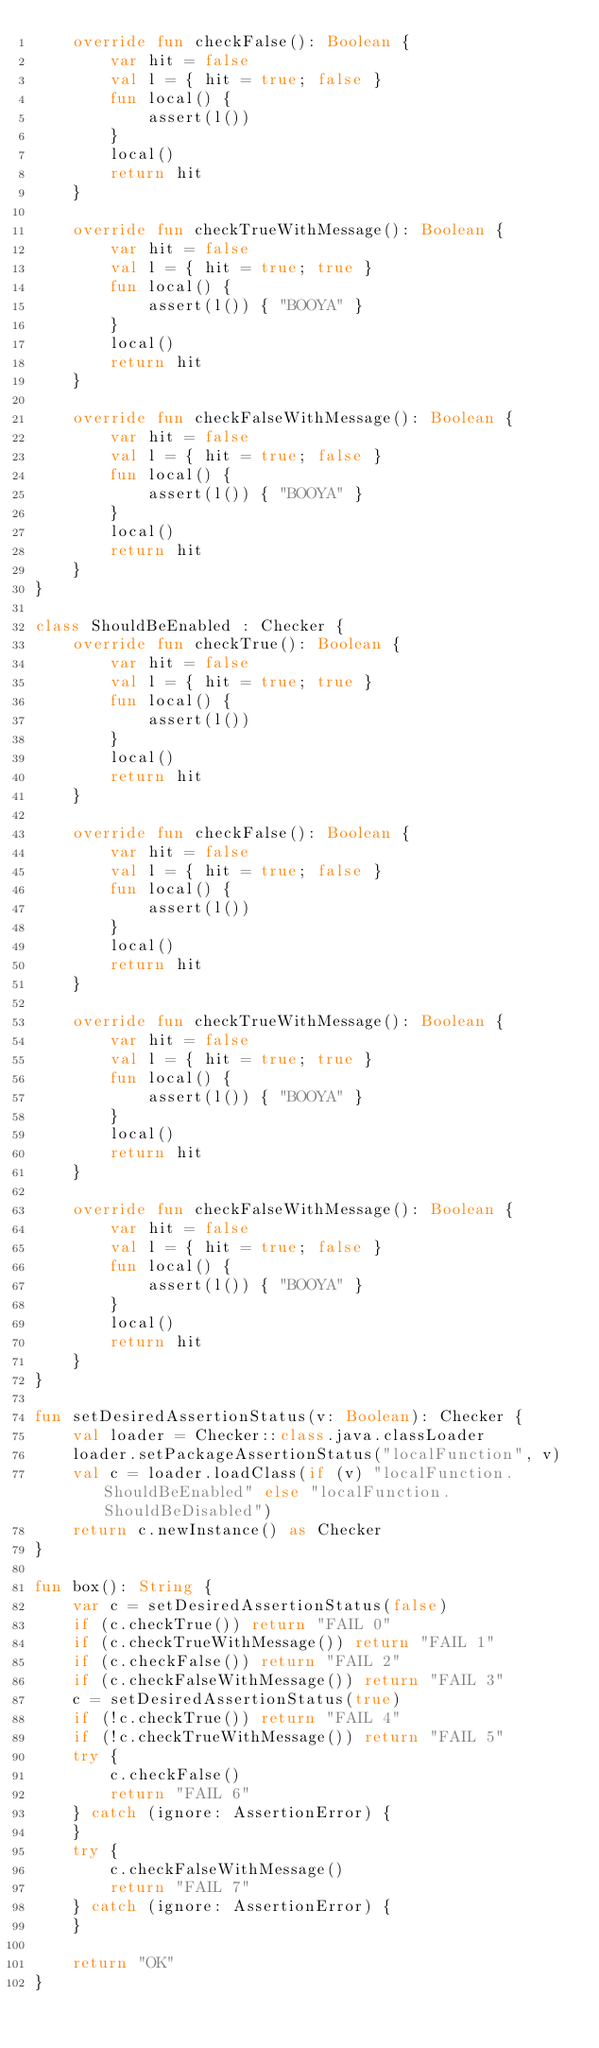<code> <loc_0><loc_0><loc_500><loc_500><_Kotlin_>    override fun checkFalse(): Boolean {
        var hit = false
        val l = { hit = true; false }
        fun local() {
            assert(l())
        }
        local()
        return hit
    }

    override fun checkTrueWithMessage(): Boolean {
        var hit = false
        val l = { hit = true; true }
        fun local() {
            assert(l()) { "BOOYA" }
        }
        local()
        return hit
    }

    override fun checkFalseWithMessage(): Boolean {
        var hit = false
        val l = { hit = true; false }
        fun local() {
            assert(l()) { "BOOYA" }
        }
        local()
        return hit
    }
}

class ShouldBeEnabled : Checker {
    override fun checkTrue(): Boolean {
        var hit = false
        val l = { hit = true; true }
        fun local() {
            assert(l())
        }
        local()
        return hit
    }

    override fun checkFalse(): Boolean {
        var hit = false
        val l = { hit = true; false }
        fun local() {
            assert(l())
        }
        local()
        return hit
    }

    override fun checkTrueWithMessage(): Boolean {
        var hit = false
        val l = { hit = true; true }
        fun local() {
            assert(l()) { "BOOYA" }
        }
        local()
        return hit
    }

    override fun checkFalseWithMessage(): Boolean {
        var hit = false
        val l = { hit = true; false }
        fun local() {
            assert(l()) { "BOOYA" }
        }
        local()
        return hit
    }
}

fun setDesiredAssertionStatus(v: Boolean): Checker {
    val loader = Checker::class.java.classLoader
    loader.setPackageAssertionStatus("localFunction", v)
    val c = loader.loadClass(if (v) "localFunction.ShouldBeEnabled" else "localFunction.ShouldBeDisabled")
    return c.newInstance() as Checker
}

fun box(): String {
    var c = setDesiredAssertionStatus(false)
    if (c.checkTrue()) return "FAIL 0"
    if (c.checkTrueWithMessage()) return "FAIL 1"
    if (c.checkFalse()) return "FAIL 2"
    if (c.checkFalseWithMessage()) return "FAIL 3"
    c = setDesiredAssertionStatus(true)
    if (!c.checkTrue()) return "FAIL 4"
    if (!c.checkTrueWithMessage()) return "FAIL 5"
    try {
        c.checkFalse()
        return "FAIL 6"
    } catch (ignore: AssertionError) {
    }
    try {
        c.checkFalseWithMessage()
        return "FAIL 7"
    } catch (ignore: AssertionError) {
    }

    return "OK"
}
</code> 